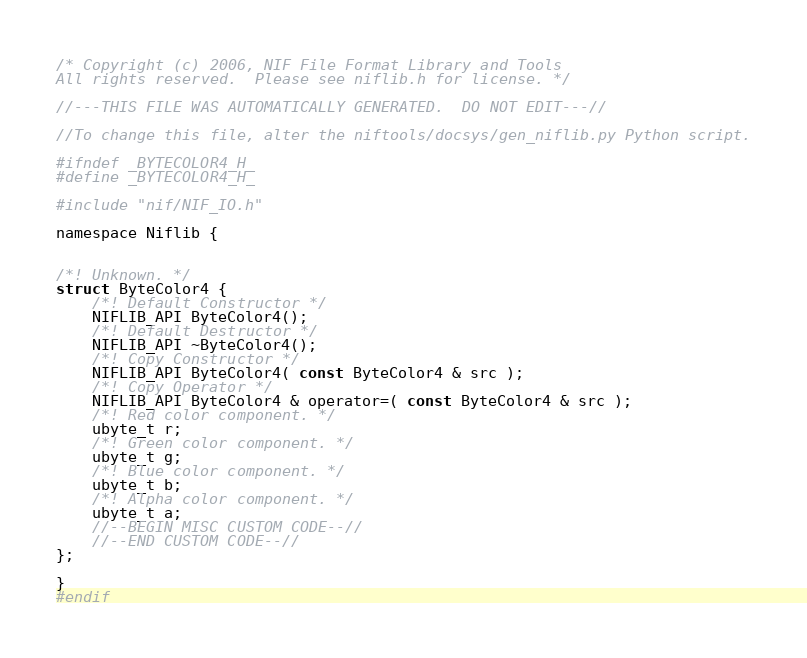Convert code to text. <code><loc_0><loc_0><loc_500><loc_500><_C_>/* Copyright (c) 2006, NIF File Format Library and Tools
All rights reserved.  Please see niflib.h for license. */

//---THIS FILE WAS AUTOMATICALLY GENERATED.  DO NOT EDIT---//

//To change this file, alter the niftools/docsys/gen_niflib.py Python script.

#ifndef _BYTECOLOR4_H_
#define _BYTECOLOR4_H_

#include "nif/NIF_IO.h"

namespace Niflib {


/*! Unknown. */
struct ByteColor4 {
	/*! Default Constructor */
	NIFLIB_API ByteColor4();
	/*! Default Destructor */
	NIFLIB_API ~ByteColor4();
	/*! Copy Constructor */
	NIFLIB_API ByteColor4( const ByteColor4 & src );
	/*! Copy Operator */
	NIFLIB_API ByteColor4 & operator=( const ByteColor4 & src );
	/*! Red color component. */
	ubyte_t r;
	/*! Green color component. */
	ubyte_t g;
	/*! Blue color component. */
	ubyte_t b;
	/*! Alpha color component. */
	ubyte_t a;
	//--BEGIN MISC CUSTOM CODE--//
	//--END CUSTOM CODE--//
};

}
#endif
</code> 